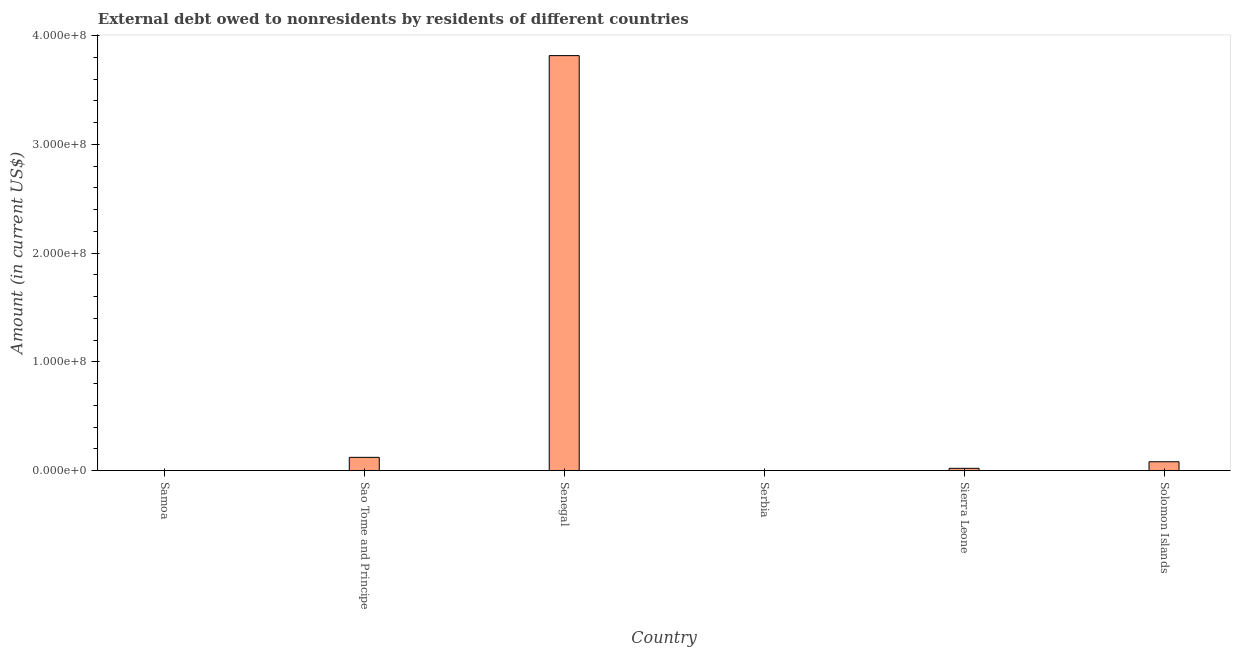Does the graph contain any zero values?
Offer a terse response. Yes. What is the title of the graph?
Keep it short and to the point. External debt owed to nonresidents by residents of different countries. What is the label or title of the X-axis?
Keep it short and to the point. Country. What is the label or title of the Y-axis?
Your answer should be compact. Amount (in current US$). What is the debt in Sierra Leone?
Make the answer very short. 2.07e+06. Across all countries, what is the maximum debt?
Your answer should be very brief. 3.82e+08. In which country was the debt maximum?
Make the answer very short. Senegal. What is the sum of the debt?
Provide a succinct answer. 4.04e+08. What is the difference between the debt in Senegal and Sierra Leone?
Your answer should be very brief. 3.80e+08. What is the average debt per country?
Give a very brief answer. 6.73e+07. What is the median debt?
Offer a terse response. 5.09e+06. In how many countries, is the debt greater than 380000000 US$?
Your answer should be very brief. 1. What is the ratio of the debt in Sao Tome and Principe to that in Senegal?
Ensure brevity in your answer.  0.03. What is the difference between the highest and the second highest debt?
Your response must be concise. 3.69e+08. What is the difference between the highest and the lowest debt?
Your answer should be very brief. 3.82e+08. What is the difference between two consecutive major ticks on the Y-axis?
Ensure brevity in your answer.  1.00e+08. Are the values on the major ticks of Y-axis written in scientific E-notation?
Provide a succinct answer. Yes. What is the Amount (in current US$) in Samoa?
Your answer should be very brief. 0. What is the Amount (in current US$) of Sao Tome and Principe?
Ensure brevity in your answer.  1.22e+07. What is the Amount (in current US$) in Senegal?
Your answer should be compact. 3.82e+08. What is the Amount (in current US$) of Sierra Leone?
Your answer should be compact. 2.07e+06. What is the Amount (in current US$) of Solomon Islands?
Keep it short and to the point. 8.11e+06. What is the difference between the Amount (in current US$) in Sao Tome and Principe and Senegal?
Your answer should be very brief. -3.69e+08. What is the difference between the Amount (in current US$) in Sao Tome and Principe and Sierra Leone?
Make the answer very short. 1.01e+07. What is the difference between the Amount (in current US$) in Sao Tome and Principe and Solomon Islands?
Give a very brief answer. 4.05e+06. What is the difference between the Amount (in current US$) in Senegal and Sierra Leone?
Provide a succinct answer. 3.80e+08. What is the difference between the Amount (in current US$) in Senegal and Solomon Islands?
Keep it short and to the point. 3.73e+08. What is the difference between the Amount (in current US$) in Sierra Leone and Solomon Islands?
Your response must be concise. -6.04e+06. What is the ratio of the Amount (in current US$) in Sao Tome and Principe to that in Senegal?
Your answer should be compact. 0.03. What is the ratio of the Amount (in current US$) in Sao Tome and Principe to that in Sierra Leone?
Keep it short and to the point. 5.87. What is the ratio of the Amount (in current US$) in Sao Tome and Principe to that in Solomon Islands?
Make the answer very short. 1.5. What is the ratio of the Amount (in current US$) in Senegal to that in Sierra Leone?
Keep it short and to the point. 184.25. What is the ratio of the Amount (in current US$) in Senegal to that in Solomon Islands?
Ensure brevity in your answer.  47.04. What is the ratio of the Amount (in current US$) in Sierra Leone to that in Solomon Islands?
Ensure brevity in your answer.  0.26. 